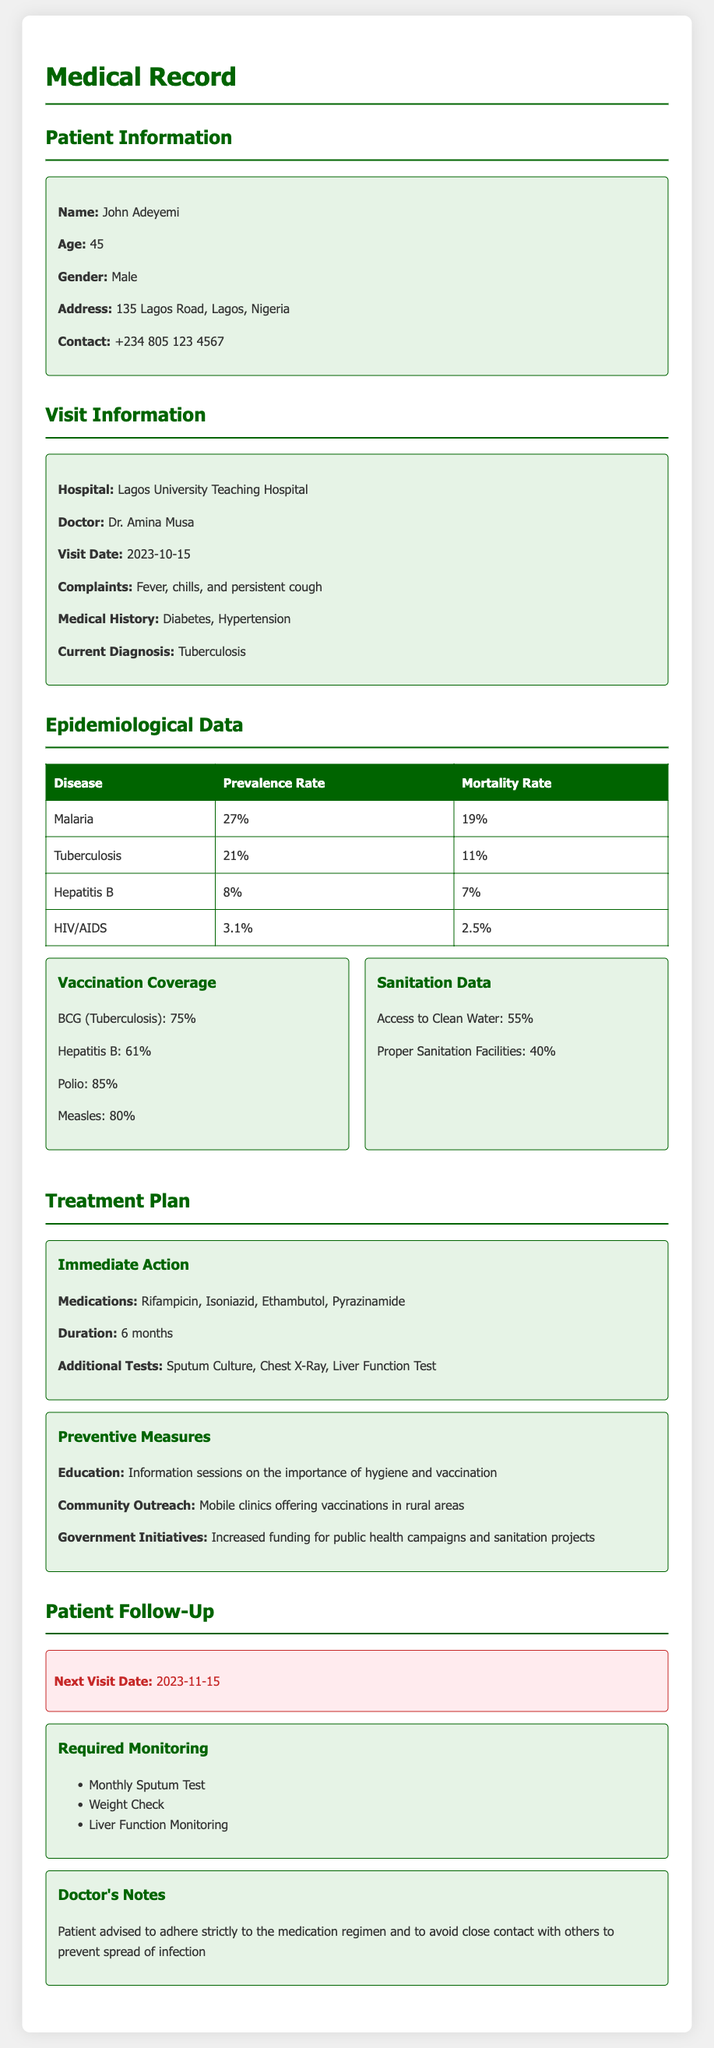What is the patient's name? The name of the patient is found under the Patient Information section.
Answer: John Adeyemi What is the current diagnosis? The current diagnosis is located in the Visit Information section.
Answer: Tuberculosis What is the visit date? The visit date can be found under the Visit Information section.
Answer: 2023-10-15 What is the prevalence rate of Malaria? The prevalence rate of Malaria is listed in the Epidemiological Data table.
Answer: 27% What medications are included in the treatment plan? The treatment plan section details the medications prescribed.
Answer: Rifampicin, Isoniazid, Ethambutol, Pyrazinamide What is the vaccination coverage for Hepatitis B? The vaccination coverage is mentioned in the Vaccination Coverage box in the Epidemiological Data section.
Answer: 61% How often will the patient need a sputum test? The monitoring section specifies the required tests and their frequency.
Answer: Monthly What are the additional tests prescribed? The additional tests are detailed in the Treatment Plan section.
Answer: Sputum Culture, Chest X-Ray, Liver Function Test What is the next visit date? The next visit date is indicated in the Patient Follow-Up section.
Answer: 2023-11-15 